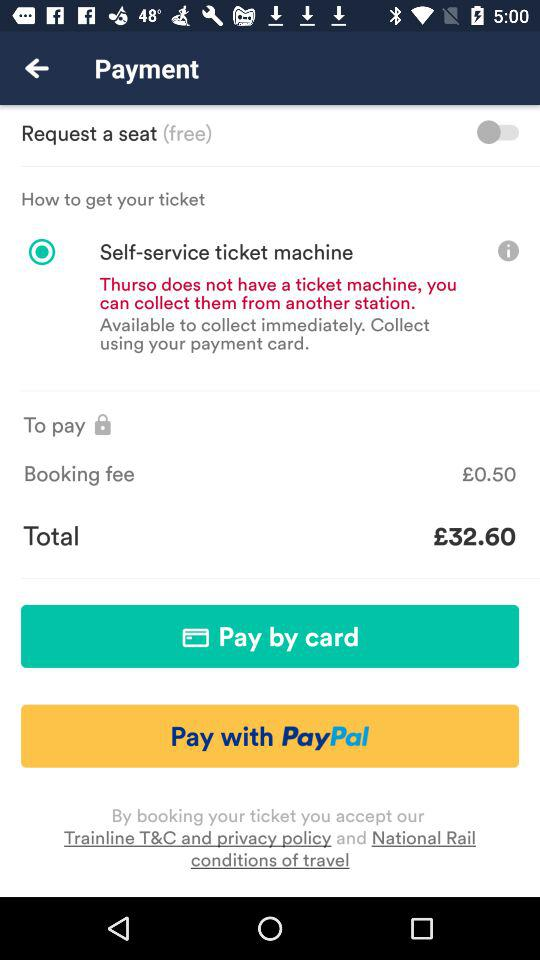What is the booking fee? The booking fee is £0.50. 